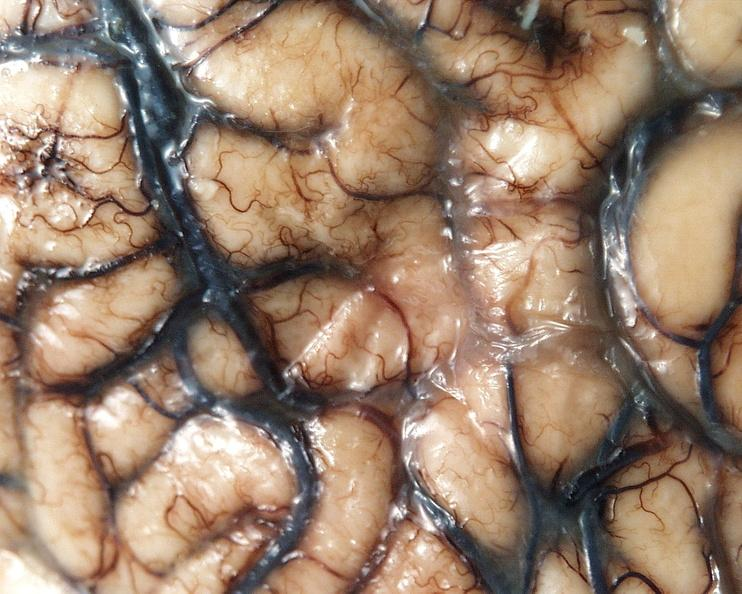s cytomegalovirus present?
Answer the question using a single word or phrase. No 